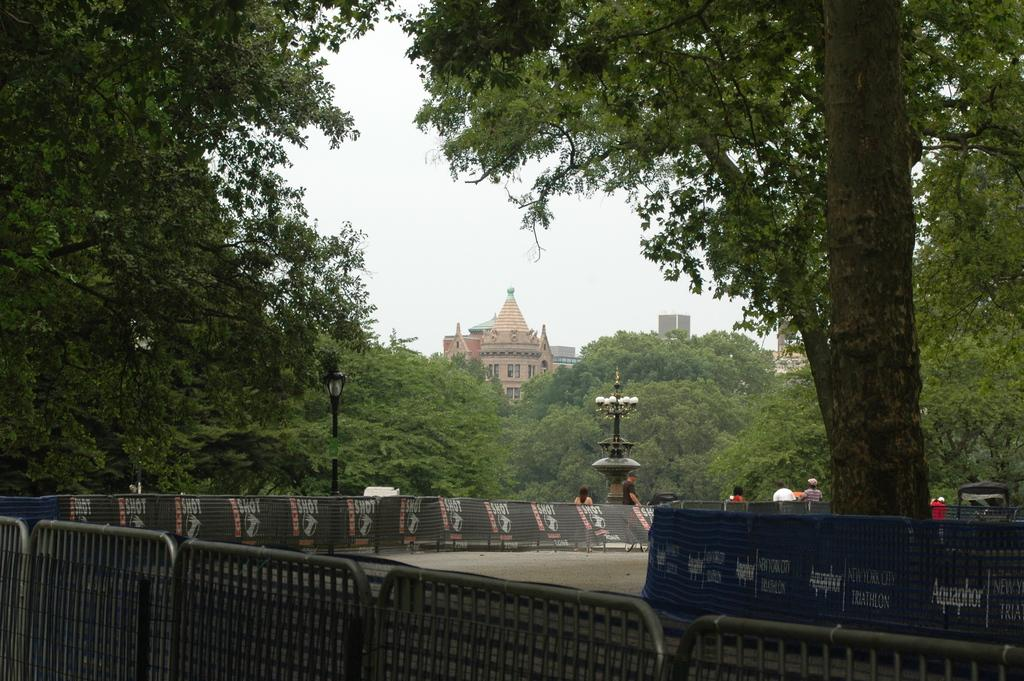What is the main structure in the center of the image? There is a building in the center of the image. What type of vegetation can be seen on both sides of the image? There are trees on both the right and left sides of the image. What other objects are present in the image? There are poles and fencing in the image. What can be seen in the background of the image? The sky is visible in the background of the image. What type of box is being used as a security measure in the image? There is no box present in the image, let alone one being used as a security measure. 